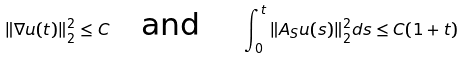<formula> <loc_0><loc_0><loc_500><loc_500>\| \nabla u ( t ) \| _ { 2 } ^ { 2 } \leq C \quad \text {and } \quad \int _ { 0 } ^ { t } \| A _ { S } u ( s ) \| _ { 2 } ^ { 2 } d s \leq C ( 1 + t )</formula> 